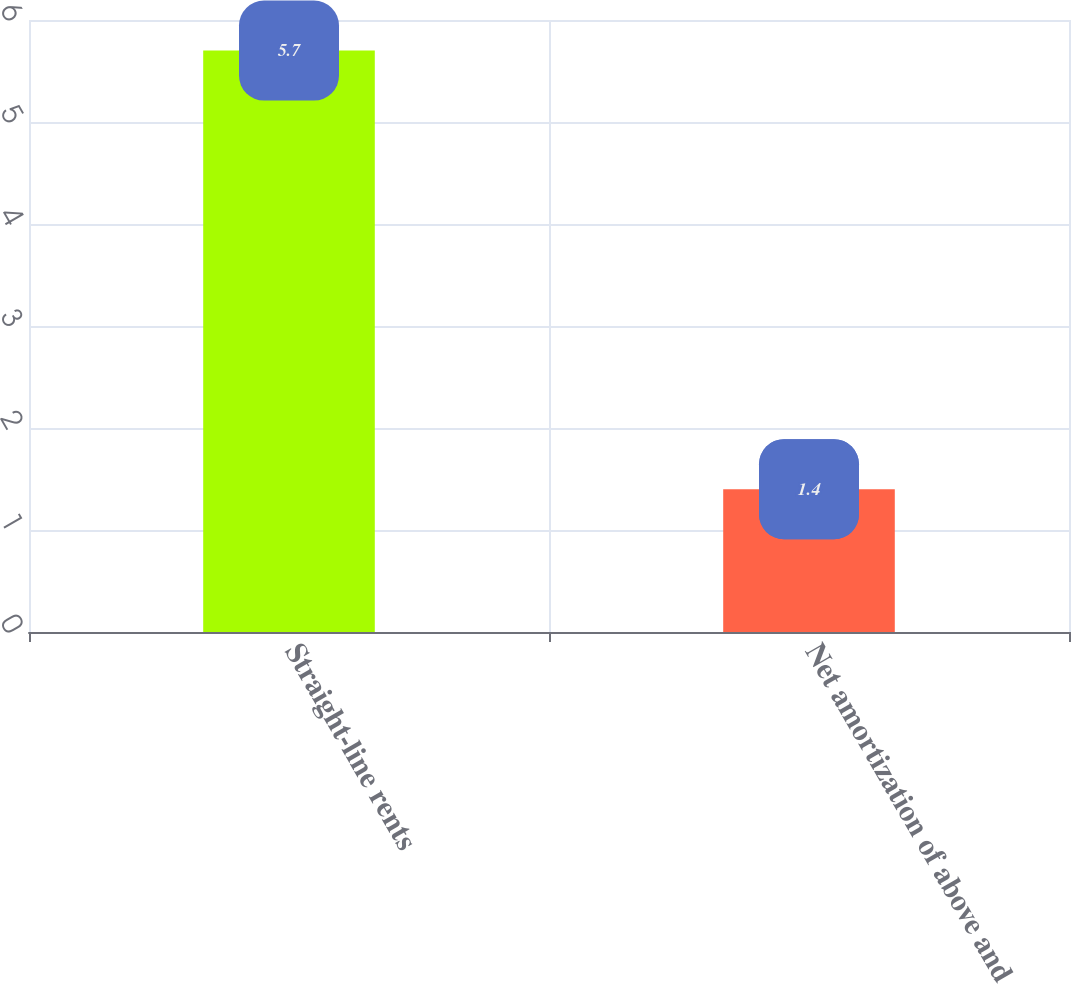Convert chart to OTSL. <chart><loc_0><loc_0><loc_500><loc_500><bar_chart><fcel>Straight-line rents<fcel>Net amortization of above and<nl><fcel>5.7<fcel>1.4<nl></chart> 